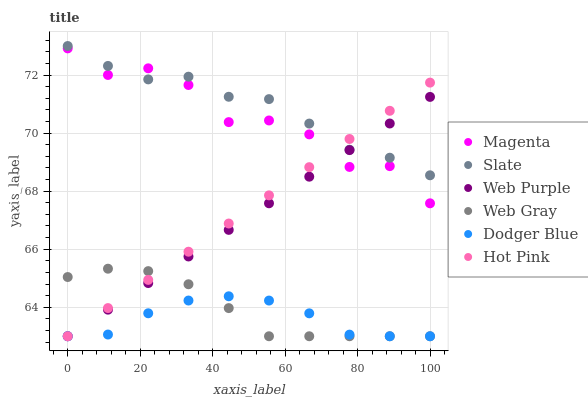Does Dodger Blue have the minimum area under the curve?
Answer yes or no. Yes. Does Slate have the maximum area under the curve?
Answer yes or no. Yes. Does Hot Pink have the minimum area under the curve?
Answer yes or no. No. Does Hot Pink have the maximum area under the curve?
Answer yes or no. No. Is Hot Pink the smoothest?
Answer yes or no. Yes. Is Magenta the roughest?
Answer yes or no. Yes. Is Slate the smoothest?
Answer yes or no. No. Is Slate the roughest?
Answer yes or no. No. Does Web Gray have the lowest value?
Answer yes or no. Yes. Does Slate have the lowest value?
Answer yes or no. No. Does Slate have the highest value?
Answer yes or no. Yes. Does Hot Pink have the highest value?
Answer yes or no. No. Is Dodger Blue less than Slate?
Answer yes or no. Yes. Is Slate greater than Dodger Blue?
Answer yes or no. Yes. Does Web Purple intersect Web Gray?
Answer yes or no. Yes. Is Web Purple less than Web Gray?
Answer yes or no. No. Is Web Purple greater than Web Gray?
Answer yes or no. No. Does Dodger Blue intersect Slate?
Answer yes or no. No. 